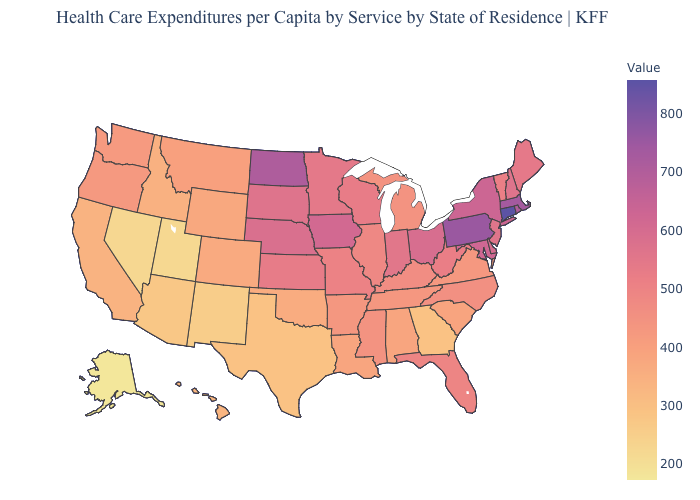Does Washington have the highest value in the USA?
Concise answer only. No. Is the legend a continuous bar?
Answer briefly. Yes. Does Maryland have the highest value in the South?
Quick response, please. Yes. Which states have the lowest value in the USA?
Short answer required. Alaska. Does Idaho have the lowest value in the USA?
Quick response, please. No. Does Vermont have the lowest value in the Northeast?
Be succinct. Yes. Does Alaska have the lowest value in the West?
Short answer required. Yes. Does the map have missing data?
Be succinct. No. 